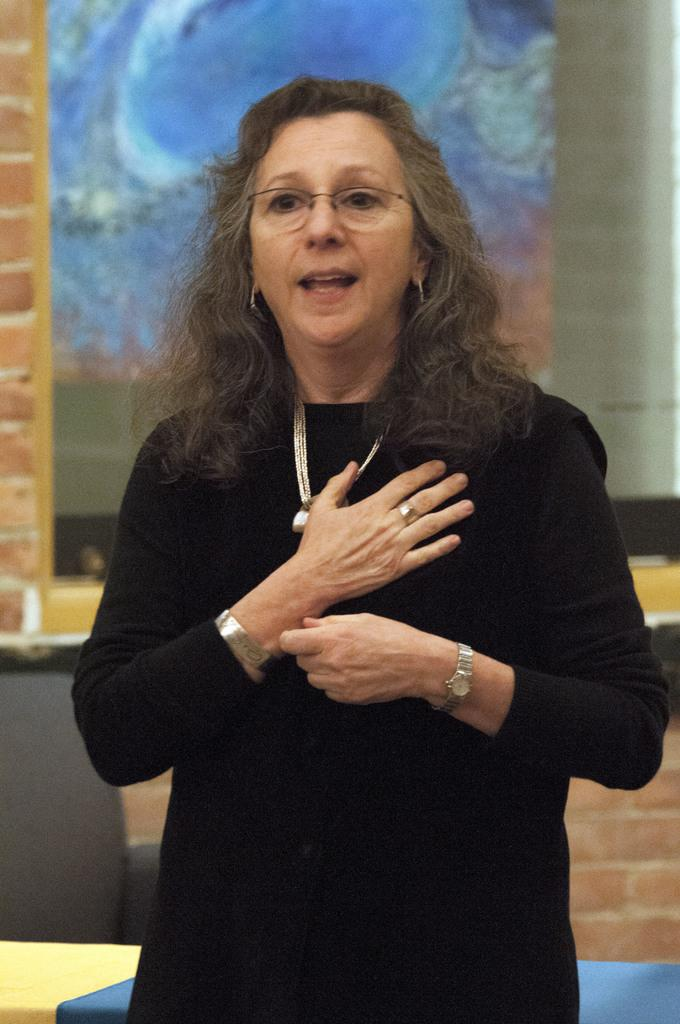What is the main subject of the image? There is a person standing in the image. What is the person wearing? The person is wearing a black dress. Can you describe the background of the image? The background of the image includes blue and brown colors. Where is the toad located in the image? There is no toad present in the image. What type of trail can be seen in the image? There is no trail present in the image. 